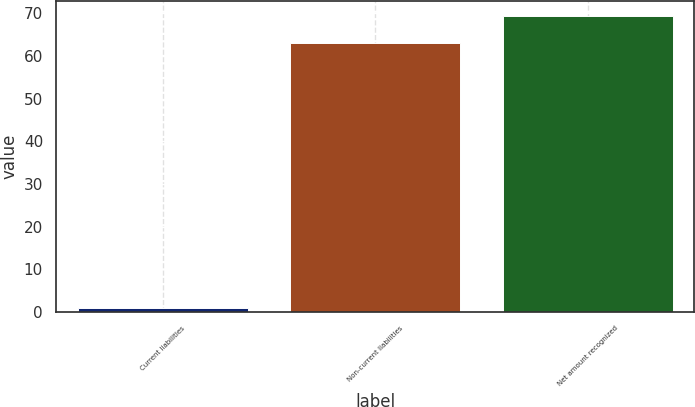Convert chart to OTSL. <chart><loc_0><loc_0><loc_500><loc_500><bar_chart><fcel>Current liabilities<fcel>Non-current liabilities<fcel>Net amount recognized<nl><fcel>1<fcel>63<fcel>69.3<nl></chart> 